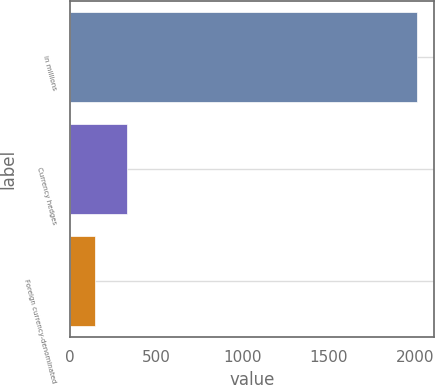Convert chart. <chart><loc_0><loc_0><loc_500><loc_500><bar_chart><fcel>in millions<fcel>Currency hedges<fcel>Foreign currency-denominated<nl><fcel>2011<fcel>333.4<fcel>147<nl></chart> 